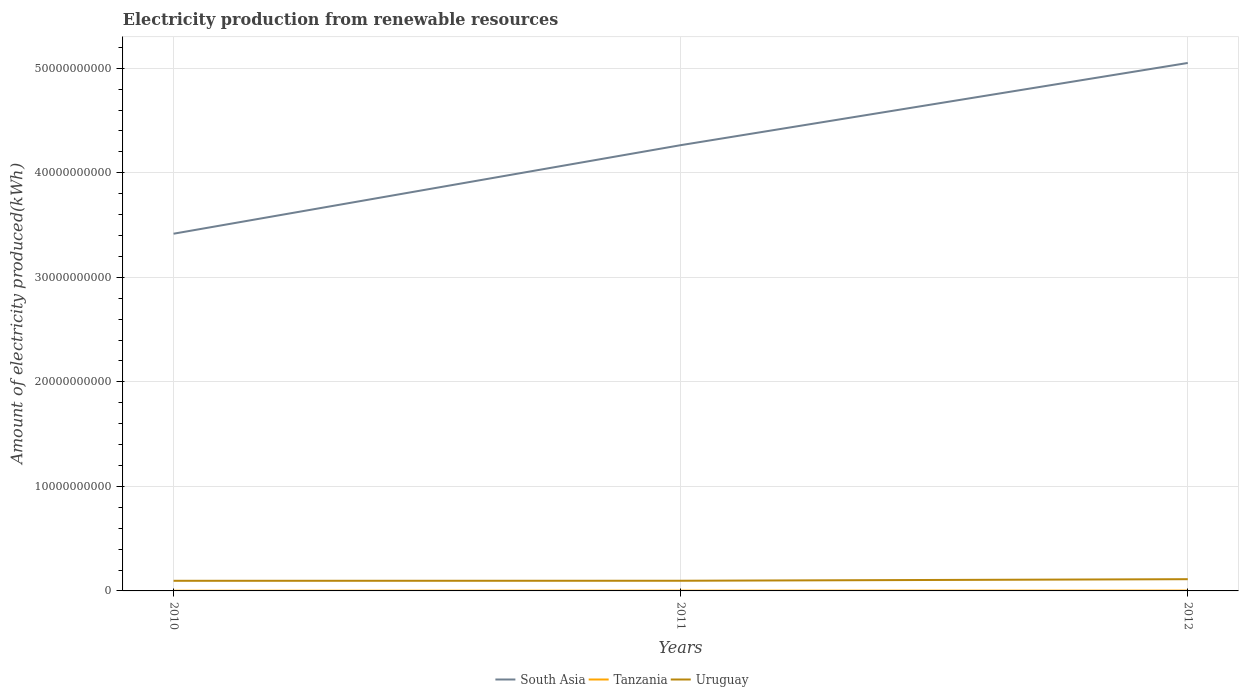Across all years, what is the maximum amount of electricity produced in Uruguay?
Make the answer very short. 9.68e+08. In which year was the amount of electricity produced in South Asia maximum?
Provide a short and direct response. 2010. What is the total amount of electricity produced in Tanzania in the graph?
Your answer should be very brief. -7.00e+06. What is the difference between the highest and the second highest amount of electricity produced in South Asia?
Provide a short and direct response. 1.63e+1. What is the difference between the highest and the lowest amount of electricity produced in Tanzania?
Your answer should be compact. 1. Does the graph contain grids?
Ensure brevity in your answer.  Yes. How many legend labels are there?
Keep it short and to the point. 3. What is the title of the graph?
Offer a terse response. Electricity production from renewable resources. Does "Least developed countries" appear as one of the legend labels in the graph?
Your response must be concise. No. What is the label or title of the Y-axis?
Give a very brief answer. Amount of electricity produced(kWh). What is the Amount of electricity produced(kWh) of South Asia in 2010?
Your answer should be compact. 3.42e+1. What is the Amount of electricity produced(kWh) of Tanzania in 2010?
Offer a terse response. 1.80e+07. What is the Amount of electricity produced(kWh) of Uruguay in 2010?
Provide a succinct answer. 9.68e+08. What is the Amount of electricity produced(kWh) of South Asia in 2011?
Give a very brief answer. 4.26e+1. What is the Amount of electricity produced(kWh) in Tanzania in 2011?
Provide a succinct answer. 2.50e+07. What is the Amount of electricity produced(kWh) in Uruguay in 2011?
Keep it short and to the point. 9.73e+08. What is the Amount of electricity produced(kWh) in South Asia in 2012?
Offer a very short reply. 5.05e+1. What is the Amount of electricity produced(kWh) in Tanzania in 2012?
Make the answer very short. 3.20e+07. What is the Amount of electricity produced(kWh) in Uruguay in 2012?
Keep it short and to the point. 1.12e+09. Across all years, what is the maximum Amount of electricity produced(kWh) of South Asia?
Your answer should be very brief. 5.05e+1. Across all years, what is the maximum Amount of electricity produced(kWh) in Tanzania?
Give a very brief answer. 3.20e+07. Across all years, what is the maximum Amount of electricity produced(kWh) of Uruguay?
Offer a terse response. 1.12e+09. Across all years, what is the minimum Amount of electricity produced(kWh) in South Asia?
Your answer should be very brief. 3.42e+1. Across all years, what is the minimum Amount of electricity produced(kWh) in Tanzania?
Your answer should be very brief. 1.80e+07. Across all years, what is the minimum Amount of electricity produced(kWh) in Uruguay?
Your answer should be compact. 9.68e+08. What is the total Amount of electricity produced(kWh) in South Asia in the graph?
Make the answer very short. 1.27e+11. What is the total Amount of electricity produced(kWh) of Tanzania in the graph?
Provide a short and direct response. 7.50e+07. What is the total Amount of electricity produced(kWh) in Uruguay in the graph?
Your answer should be very brief. 3.06e+09. What is the difference between the Amount of electricity produced(kWh) of South Asia in 2010 and that in 2011?
Offer a very short reply. -8.47e+09. What is the difference between the Amount of electricity produced(kWh) of Tanzania in 2010 and that in 2011?
Give a very brief answer. -7.00e+06. What is the difference between the Amount of electricity produced(kWh) in Uruguay in 2010 and that in 2011?
Provide a succinct answer. -5.00e+06. What is the difference between the Amount of electricity produced(kWh) of South Asia in 2010 and that in 2012?
Keep it short and to the point. -1.63e+1. What is the difference between the Amount of electricity produced(kWh) in Tanzania in 2010 and that in 2012?
Give a very brief answer. -1.40e+07. What is the difference between the Amount of electricity produced(kWh) of Uruguay in 2010 and that in 2012?
Your answer should be very brief. -1.54e+08. What is the difference between the Amount of electricity produced(kWh) of South Asia in 2011 and that in 2012?
Offer a terse response. -7.86e+09. What is the difference between the Amount of electricity produced(kWh) in Tanzania in 2011 and that in 2012?
Keep it short and to the point. -7.00e+06. What is the difference between the Amount of electricity produced(kWh) of Uruguay in 2011 and that in 2012?
Offer a very short reply. -1.49e+08. What is the difference between the Amount of electricity produced(kWh) of South Asia in 2010 and the Amount of electricity produced(kWh) of Tanzania in 2011?
Your response must be concise. 3.41e+1. What is the difference between the Amount of electricity produced(kWh) in South Asia in 2010 and the Amount of electricity produced(kWh) in Uruguay in 2011?
Your answer should be very brief. 3.32e+1. What is the difference between the Amount of electricity produced(kWh) in Tanzania in 2010 and the Amount of electricity produced(kWh) in Uruguay in 2011?
Provide a short and direct response. -9.55e+08. What is the difference between the Amount of electricity produced(kWh) of South Asia in 2010 and the Amount of electricity produced(kWh) of Tanzania in 2012?
Provide a short and direct response. 3.41e+1. What is the difference between the Amount of electricity produced(kWh) of South Asia in 2010 and the Amount of electricity produced(kWh) of Uruguay in 2012?
Your answer should be compact. 3.30e+1. What is the difference between the Amount of electricity produced(kWh) in Tanzania in 2010 and the Amount of electricity produced(kWh) in Uruguay in 2012?
Your response must be concise. -1.10e+09. What is the difference between the Amount of electricity produced(kWh) of South Asia in 2011 and the Amount of electricity produced(kWh) of Tanzania in 2012?
Offer a very short reply. 4.26e+1. What is the difference between the Amount of electricity produced(kWh) of South Asia in 2011 and the Amount of electricity produced(kWh) of Uruguay in 2012?
Your answer should be compact. 4.15e+1. What is the difference between the Amount of electricity produced(kWh) of Tanzania in 2011 and the Amount of electricity produced(kWh) of Uruguay in 2012?
Provide a succinct answer. -1.10e+09. What is the average Amount of electricity produced(kWh) of South Asia per year?
Provide a succinct answer. 4.24e+1. What is the average Amount of electricity produced(kWh) in Tanzania per year?
Keep it short and to the point. 2.50e+07. What is the average Amount of electricity produced(kWh) of Uruguay per year?
Offer a very short reply. 1.02e+09. In the year 2010, what is the difference between the Amount of electricity produced(kWh) in South Asia and Amount of electricity produced(kWh) in Tanzania?
Provide a succinct answer. 3.42e+1. In the year 2010, what is the difference between the Amount of electricity produced(kWh) of South Asia and Amount of electricity produced(kWh) of Uruguay?
Provide a short and direct response. 3.32e+1. In the year 2010, what is the difference between the Amount of electricity produced(kWh) of Tanzania and Amount of electricity produced(kWh) of Uruguay?
Your answer should be very brief. -9.50e+08. In the year 2011, what is the difference between the Amount of electricity produced(kWh) in South Asia and Amount of electricity produced(kWh) in Tanzania?
Keep it short and to the point. 4.26e+1. In the year 2011, what is the difference between the Amount of electricity produced(kWh) in South Asia and Amount of electricity produced(kWh) in Uruguay?
Keep it short and to the point. 4.17e+1. In the year 2011, what is the difference between the Amount of electricity produced(kWh) in Tanzania and Amount of electricity produced(kWh) in Uruguay?
Offer a terse response. -9.48e+08. In the year 2012, what is the difference between the Amount of electricity produced(kWh) in South Asia and Amount of electricity produced(kWh) in Tanzania?
Ensure brevity in your answer.  5.05e+1. In the year 2012, what is the difference between the Amount of electricity produced(kWh) in South Asia and Amount of electricity produced(kWh) in Uruguay?
Ensure brevity in your answer.  4.94e+1. In the year 2012, what is the difference between the Amount of electricity produced(kWh) of Tanzania and Amount of electricity produced(kWh) of Uruguay?
Keep it short and to the point. -1.09e+09. What is the ratio of the Amount of electricity produced(kWh) in South Asia in 2010 to that in 2011?
Keep it short and to the point. 0.8. What is the ratio of the Amount of electricity produced(kWh) of Tanzania in 2010 to that in 2011?
Offer a terse response. 0.72. What is the ratio of the Amount of electricity produced(kWh) in South Asia in 2010 to that in 2012?
Make the answer very short. 0.68. What is the ratio of the Amount of electricity produced(kWh) in Tanzania in 2010 to that in 2012?
Your response must be concise. 0.56. What is the ratio of the Amount of electricity produced(kWh) of Uruguay in 2010 to that in 2012?
Offer a very short reply. 0.86. What is the ratio of the Amount of electricity produced(kWh) of South Asia in 2011 to that in 2012?
Give a very brief answer. 0.84. What is the ratio of the Amount of electricity produced(kWh) of Tanzania in 2011 to that in 2012?
Your answer should be very brief. 0.78. What is the ratio of the Amount of electricity produced(kWh) in Uruguay in 2011 to that in 2012?
Provide a succinct answer. 0.87. What is the difference between the highest and the second highest Amount of electricity produced(kWh) in South Asia?
Give a very brief answer. 7.86e+09. What is the difference between the highest and the second highest Amount of electricity produced(kWh) in Tanzania?
Provide a succinct answer. 7.00e+06. What is the difference between the highest and the second highest Amount of electricity produced(kWh) in Uruguay?
Provide a succinct answer. 1.49e+08. What is the difference between the highest and the lowest Amount of electricity produced(kWh) of South Asia?
Give a very brief answer. 1.63e+1. What is the difference between the highest and the lowest Amount of electricity produced(kWh) in Tanzania?
Offer a terse response. 1.40e+07. What is the difference between the highest and the lowest Amount of electricity produced(kWh) of Uruguay?
Your answer should be compact. 1.54e+08. 